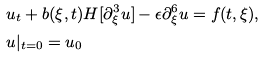<formula> <loc_0><loc_0><loc_500><loc_500>& u _ { t } + b ( \xi , t ) H [ \partial ^ { 3 } _ { \xi } u ] - \epsilon \partial ^ { 6 } _ { \xi } u = f ( t , \xi ) , \\ & u | _ { t = 0 } = u _ { 0 }</formula> 